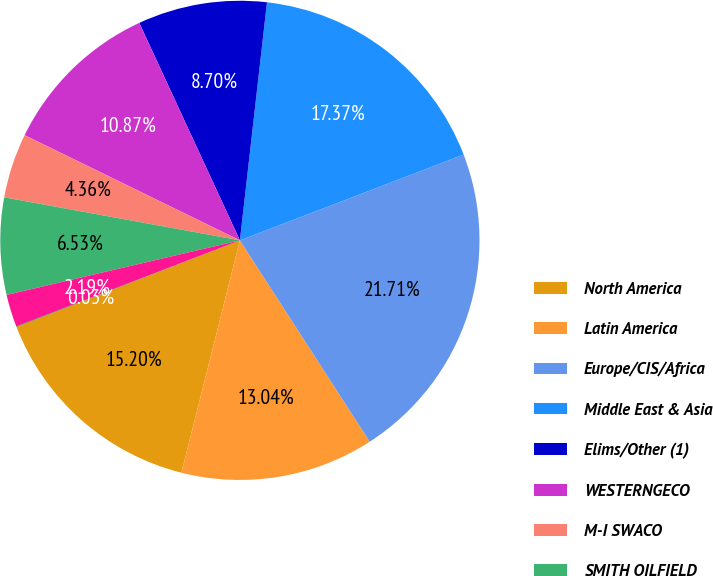Convert chart to OTSL. <chart><loc_0><loc_0><loc_500><loc_500><pie_chart><fcel>North America<fcel>Latin America<fcel>Europe/CIS/Africa<fcel>Middle East & Asia<fcel>Elims/Other (1)<fcel>WESTERNGECO<fcel>M-I SWACO<fcel>SMITH OILFIELD<fcel>DISTRIBUTION<fcel>Corporate (2)<nl><fcel>15.2%<fcel>13.04%<fcel>21.71%<fcel>17.37%<fcel>8.7%<fcel>10.87%<fcel>4.36%<fcel>6.53%<fcel>2.19%<fcel>0.03%<nl></chart> 